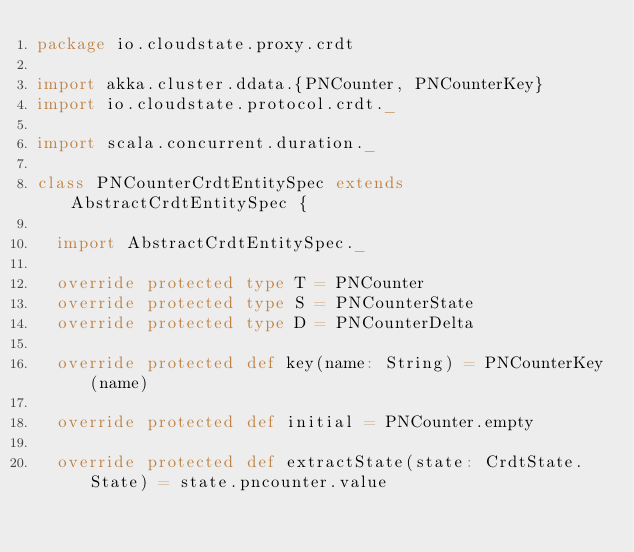<code> <loc_0><loc_0><loc_500><loc_500><_Scala_>package io.cloudstate.proxy.crdt

import akka.cluster.ddata.{PNCounter, PNCounterKey}
import io.cloudstate.protocol.crdt._

import scala.concurrent.duration._

class PNCounterCrdtEntitySpec extends AbstractCrdtEntitySpec {

  import AbstractCrdtEntitySpec._

  override protected type T = PNCounter
  override protected type S = PNCounterState
  override protected type D = PNCounterDelta

  override protected def key(name: String) = PNCounterKey(name)

  override protected def initial = PNCounter.empty

  override protected def extractState(state: CrdtState.State) = state.pncounter.value
</code> 